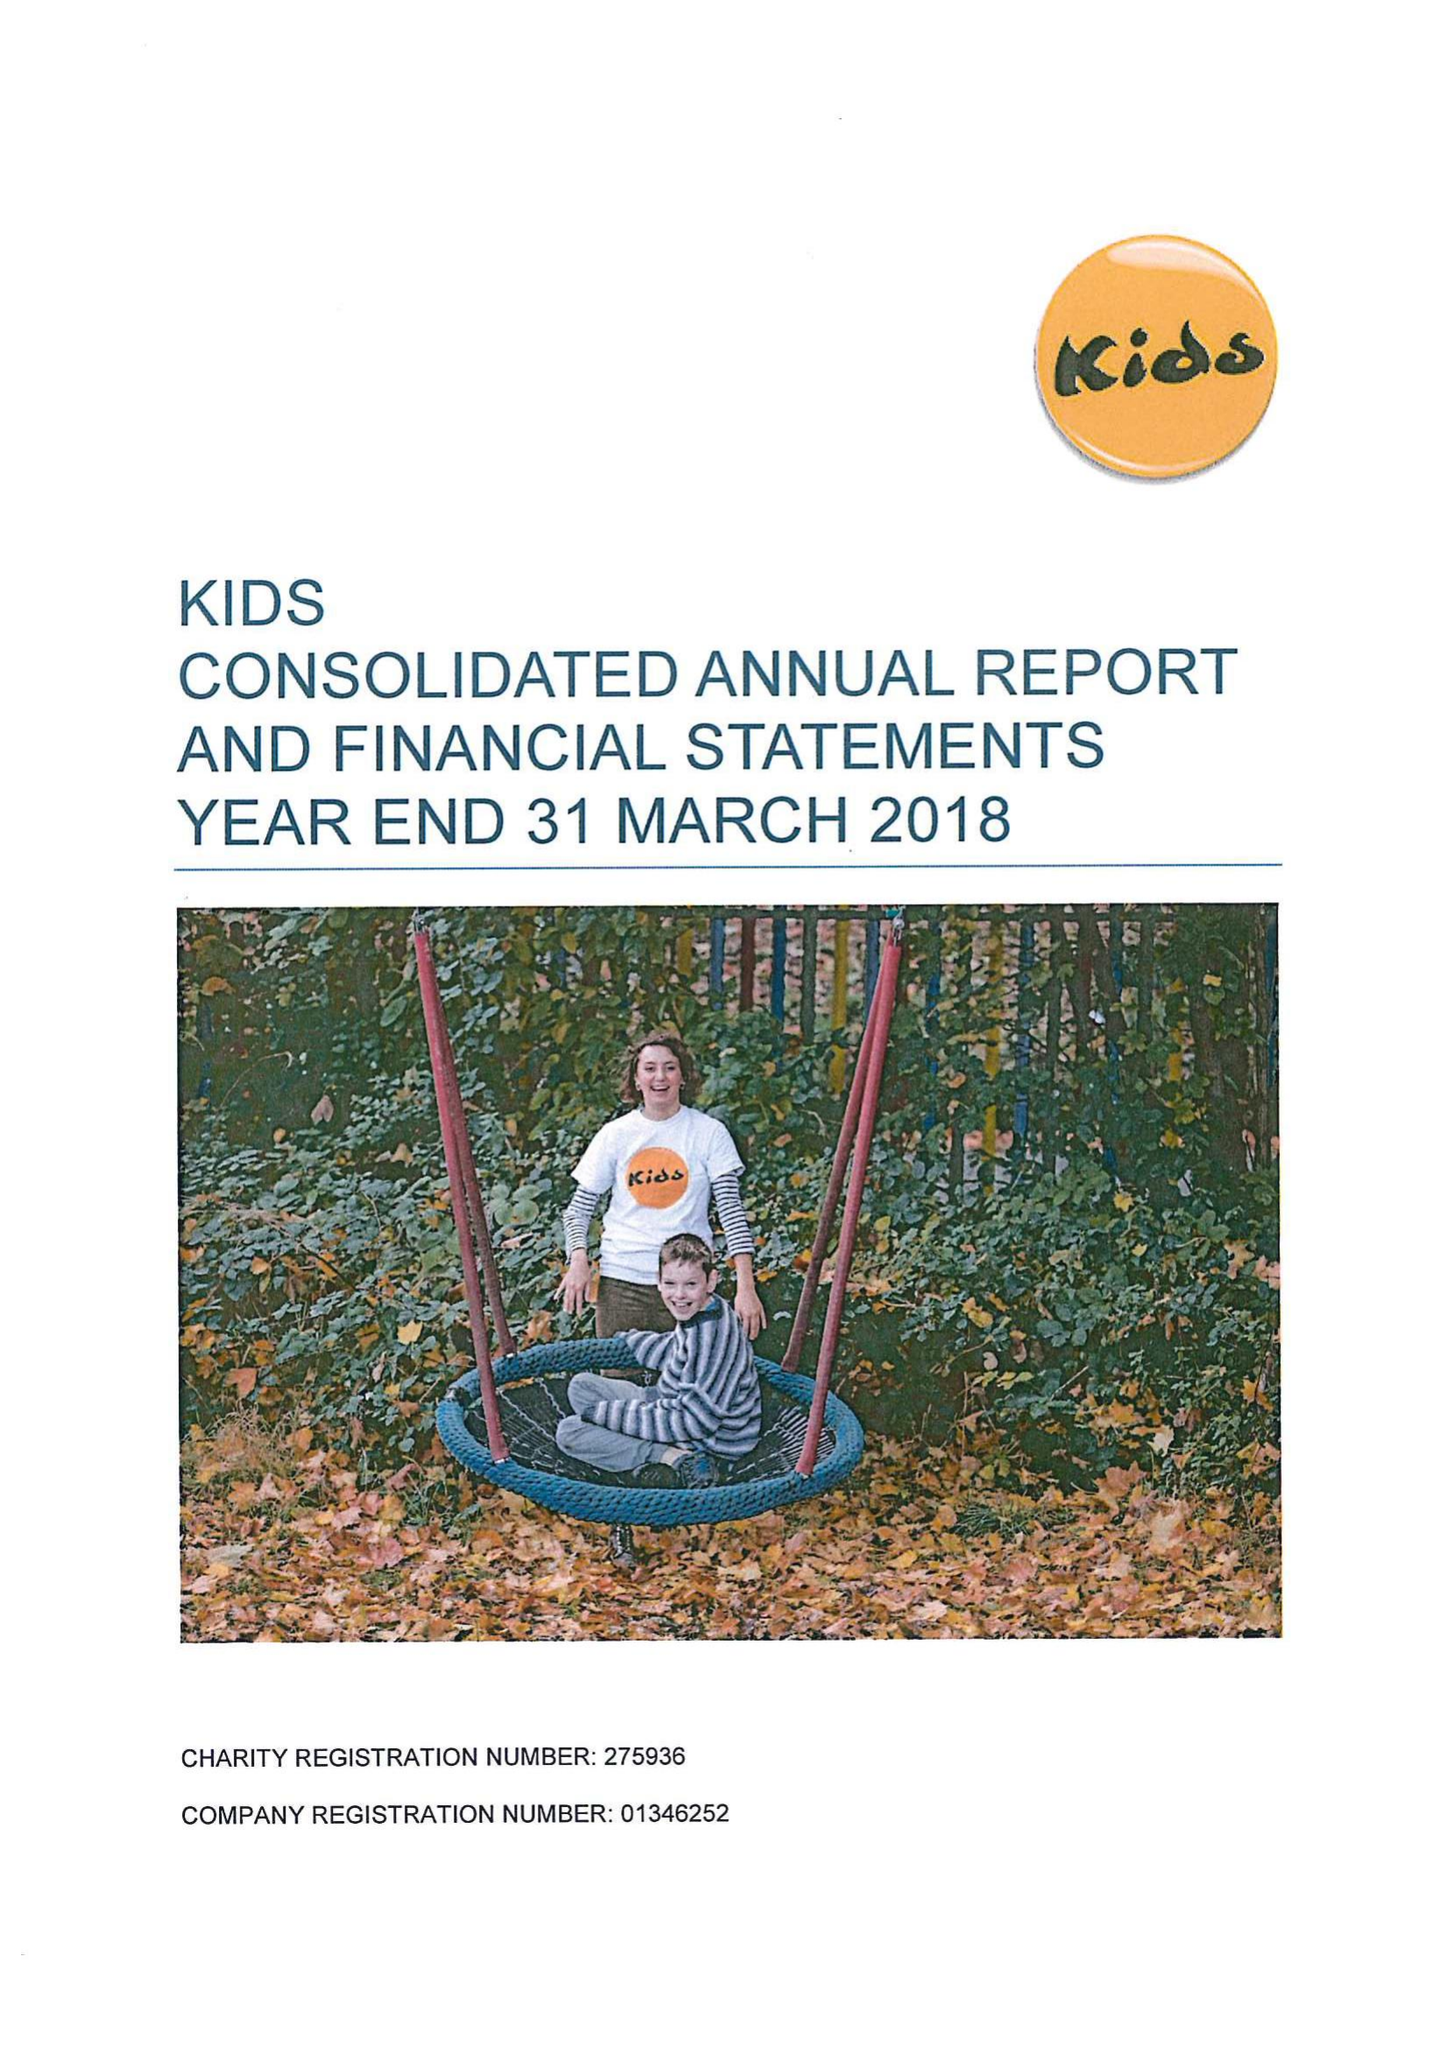What is the value for the address__postcode?
Answer the question using a single word or phrase. N1 8HX 